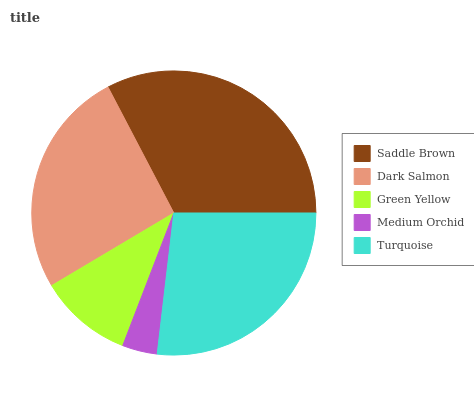Is Medium Orchid the minimum?
Answer yes or no. Yes. Is Saddle Brown the maximum?
Answer yes or no. Yes. Is Dark Salmon the minimum?
Answer yes or no. No. Is Dark Salmon the maximum?
Answer yes or no. No. Is Saddle Brown greater than Dark Salmon?
Answer yes or no. Yes. Is Dark Salmon less than Saddle Brown?
Answer yes or no. Yes. Is Dark Salmon greater than Saddle Brown?
Answer yes or no. No. Is Saddle Brown less than Dark Salmon?
Answer yes or no. No. Is Dark Salmon the high median?
Answer yes or no. Yes. Is Dark Salmon the low median?
Answer yes or no. Yes. Is Medium Orchid the high median?
Answer yes or no. No. Is Turquoise the low median?
Answer yes or no. No. 